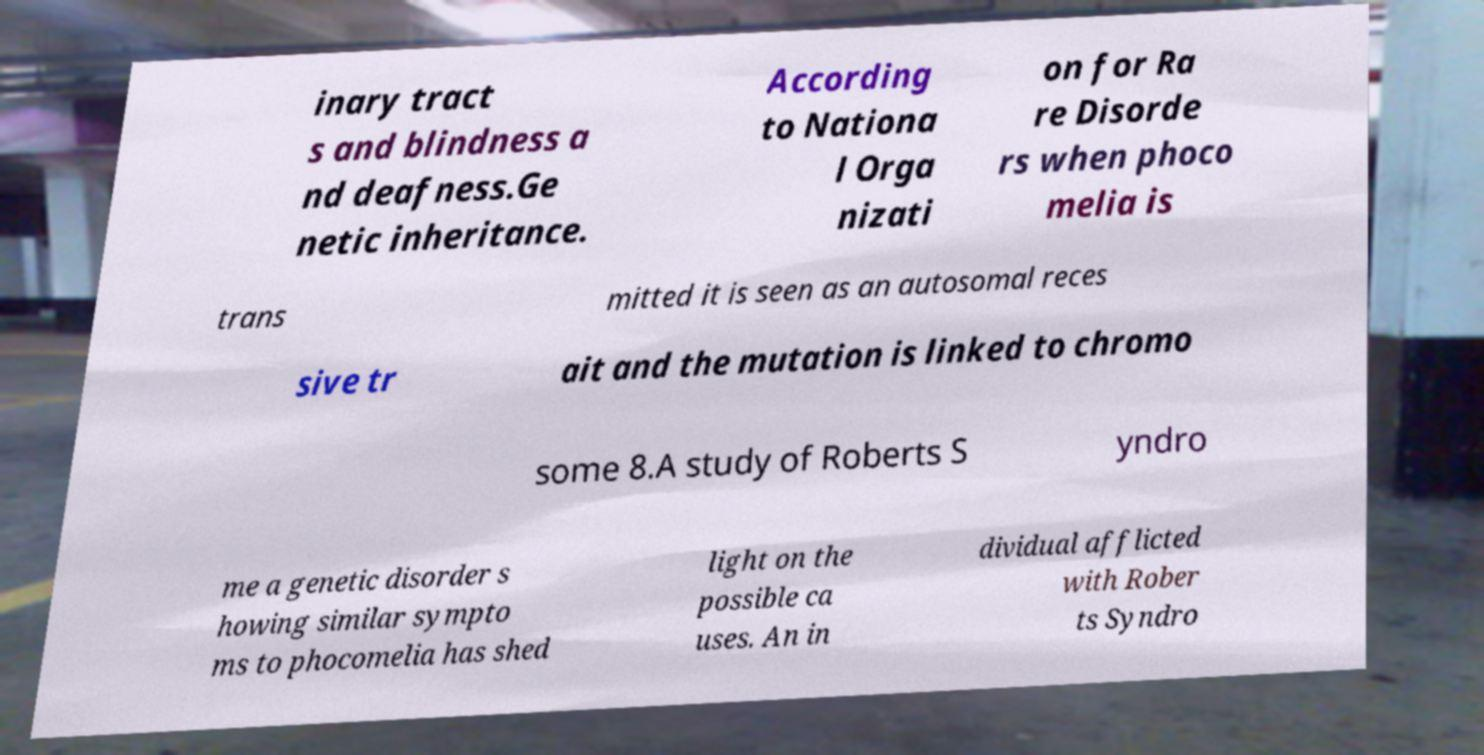Please read and relay the text visible in this image. What does it say? inary tract s and blindness a nd deafness.Ge netic inheritance. According to Nationa l Orga nizati on for Ra re Disorde rs when phoco melia is trans mitted it is seen as an autosomal reces sive tr ait and the mutation is linked to chromo some 8.A study of Roberts S yndro me a genetic disorder s howing similar sympto ms to phocomelia has shed light on the possible ca uses. An in dividual afflicted with Rober ts Syndro 